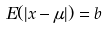Convert formula to latex. <formula><loc_0><loc_0><loc_500><loc_500>E ( | x - \mu | ) = b</formula> 